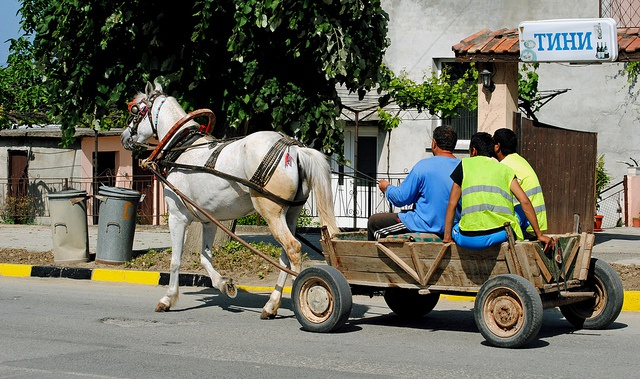Describe the objects in this image and their specific colors. I can see horse in darkgray, lightgray, black, and gray tones, people in darkgray, black, lightgreen, and khaki tones, people in darkgray, lightblue, black, and gray tones, and people in darkgray, black, khaki, and maroon tones in this image. 